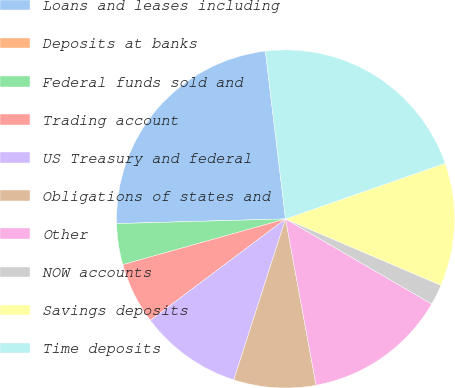Convert chart. <chart><loc_0><loc_0><loc_500><loc_500><pie_chart><fcel>Loans and leases including<fcel>Deposits at banks<fcel>Federal funds sold and<fcel>Trading account<fcel>US Treasury and federal<fcel>Obligations of states and<fcel>Other<fcel>NOW accounts<fcel>Savings deposits<fcel>Time deposits<nl><fcel>23.52%<fcel>0.0%<fcel>3.92%<fcel>5.88%<fcel>9.8%<fcel>7.84%<fcel>13.72%<fcel>1.96%<fcel>11.76%<fcel>21.56%<nl></chart> 